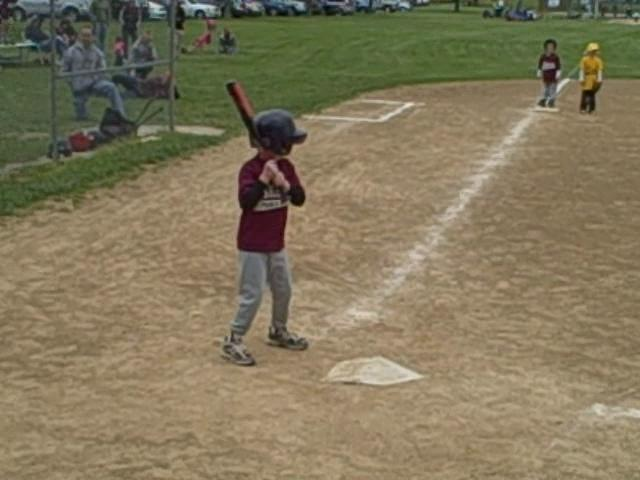What position does the player wearing yellow play? Please explain your reasoning. third base. The position is third base. 